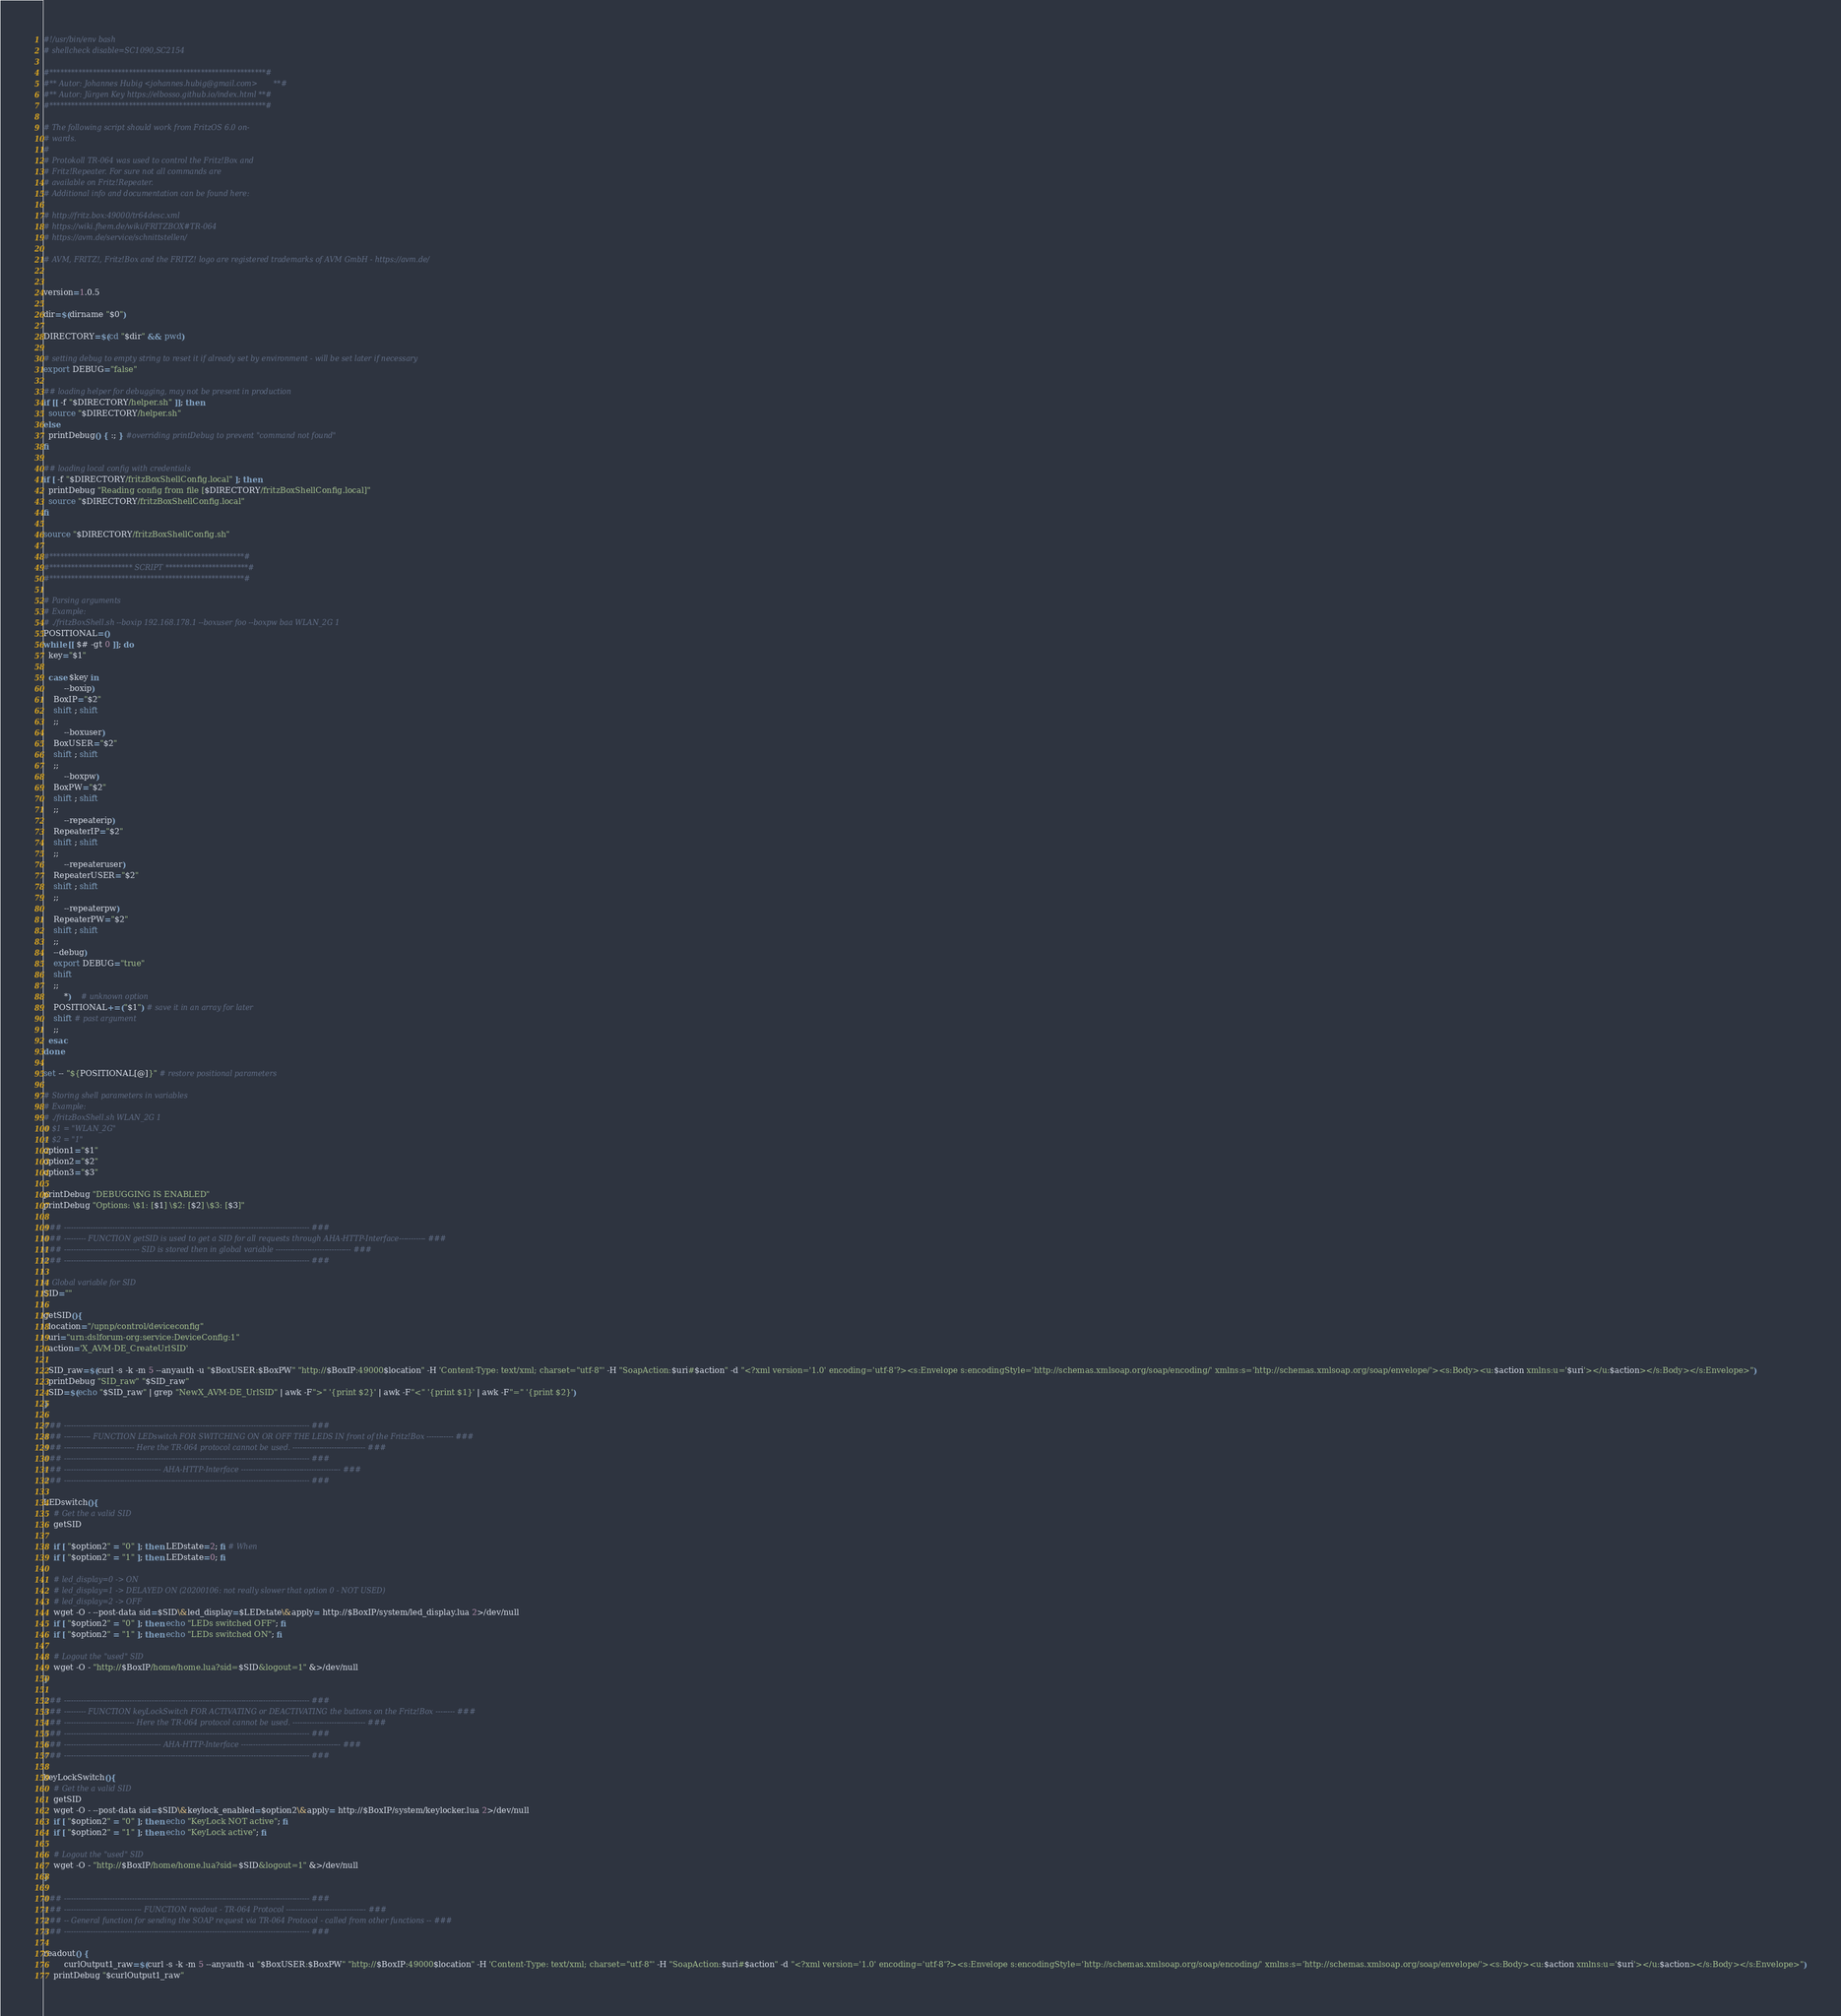<code> <loc_0><loc_0><loc_500><loc_500><_Bash_>#!/usr/bin/env bash
# shellcheck disable=SC1090,SC2154

#************************************************************#
#** Autor: Johannes Hubig <johannes.hubig@gmail.com>       **#
#** Autor: Jürgen Key https://elbosso.github.io/index.html **#
#************************************************************#

# The following script should work from FritzOS 6.0 on-
# wards.
#
# Protokoll TR-064 was used to control the Fritz!Box and
# Fritz!Repeater. For sure not all commands are
# available on Fritz!Repeater.
# Additional info and documentation can be found here:

# http://fritz.box:49000/tr64desc.xml
# https://wiki.fhem.de/wiki/FRITZBOX#TR-064
# https://avm.de/service/schnittstellen/

# AVM, FRITZ!, Fritz!Box and the FRITZ! logo are registered trademarks of AVM GmbH - https://avm.de/


version=1.0.5

dir=$(dirname "$0")

DIRECTORY=$(cd "$dir" && pwd)

# setting debug to empty string to reset it if already set by environment - will be set later if necessary
export DEBUG="false"

## loading helper for debugging, may not be present in production
if [[ -f "$DIRECTORY/helper.sh" ]]; then
  source "$DIRECTORY/helper.sh"
else
  printDebug() { :; } #overriding printDebug to prevent "command not found"
fi

## loading local config with credentials
if [ -f "$DIRECTORY/fritzBoxShellConfig.local" ]; then
  printDebug "Reading config from file [$DIRECTORY/fritzBoxShellConfig.local]"
  source "$DIRECTORY/fritzBoxShellConfig.local"
fi

source "$DIRECTORY/fritzBoxShellConfig.sh"

#******************************************************#
#*********************** SCRIPT ***********************#
#******************************************************#

# Parsing arguments
# Example:
# ./fritzBoxShell.sh --boxip 192.168.178.1 --boxuser foo --boxpw baa WLAN_2G 1
POSITIONAL=()
while [[ $# -gt 0 ]]; do
  key="$1"

  case $key in
		--boxip)
    BoxIP="$2"
    shift ; shift
    ;;
		--boxuser)
    BoxUSER="$2"
    shift ; shift
    ;;
		--boxpw)
    BoxPW="$2"
    shift ; shift
    ;;
		--repeaterip)
    RepeaterIP="$2"
    shift ; shift
    ;;
		--repeateruser)
    RepeaterUSER="$2"
    shift ; shift
    ;;
		--repeaterpw)
    RepeaterPW="$2"
    shift ; shift
    ;;
    --debug)
    export DEBUG="true"
    shift
    ;;
		*)    # unknown option
    POSITIONAL+=("$1") # save it in an array for later
    shift # past argument
    ;;
  esac
done

set -- "${POSITIONAL[@]}" # restore positional parameters

# Storing shell parameters in variables
# Example:
# ./fritzBoxShell.sh WLAN_2G 1
# $1 = "WLAN_2G"
# $2 = "1"
option1="$1"
option2="$2"
option3="$3"

printDebug "DEBUGGING IS ENABLED"
printDebug "Options: \$1: [$1] \$2: [$2] \$3: [$3]"

### ----------------------------------------------------------------------------------------------------- ###
### --------- FUNCTION getSID is used to get a SID for all requests through AHA-HTTP-Interface----------- ###
### ------------------------------- SID is stored then in global variable ------------------------------- ###
### ----------------------------------------------------------------------------------------------------- ###

# Global variable for SID
SID=""

getSID(){
  location="/upnp/control/deviceconfig"
  uri="urn:dslforum-org:service:DeviceConfig:1"
  action='X_AVM-DE_CreateUrlSID'

  SID_raw=$(curl -s -k -m 5 --anyauth -u "$BoxUSER:$BoxPW" "http://$BoxIP:49000$location" -H 'Content-Type: text/xml; charset="utf-8"' -H "SoapAction:$uri#$action" -d "<?xml version='1.0' encoding='utf-8'?><s:Envelope s:encodingStyle='http://schemas.xmlsoap.org/soap/encoding/' xmlns:s='http://schemas.xmlsoap.org/soap/envelope/'><s:Body><u:$action xmlns:u='$uri'></u:$action></s:Body></s:Envelope>")
  printDebug "SID_raw" "$SID_raw"
  SID=$(echo "$SID_raw" | grep "NewX_AVM-DE_UrlSID" | awk -F">" '{print $2}' | awk -F"<" '{print $1}' | awk -F"=" '{print $2}')
}

### ----------------------------------------------------------------------------------------------------- ###
### ----------- FUNCTION LEDswitch FOR SWITCHING ON OR OFF THE LEDS IN front of the Fritz!Box ----------- ###
### ----------------------------- Here the TR-064 protocol cannot be used. ------------------------------ ###
### ----------------------------------------------------------------------------------------------------- ###
### ---------------------------------------- AHA-HTTP-Interface ----------------------------------------- ###
### ----------------------------------------------------------------------------------------------------- ###

LEDswitch(){
	# Get the a valid SID
	getSID

	if [ "$option2" = "0" ]; then LEDstate=2; fi # When
	if [ "$option2" = "1" ]; then LEDstate=0; fi

	# led_display=0 -> ON
	# led_display=1 -> DELAYED ON (20200106: not really slower that option 0 - NOT USED)
	# led_display=2 -> OFF
	wget -O - --post-data sid=$SID\&led_display=$LEDstate\&apply= http://$BoxIP/system/led_display.lua 2>/dev/null
	if [ "$option2" = "0" ]; then echo "LEDs switched OFF"; fi
	if [ "$option2" = "1" ]; then echo "LEDs switched ON"; fi

	# Logout the "used" SID
	wget -O - "http://$BoxIP/home/home.lua?sid=$SID&logout=1" &>/dev/null
}

### ----------------------------------------------------------------------------------------------------- ###
### --------- FUNCTION keyLockSwitch FOR ACTIVATING or DEACTIVATING the buttons on the Fritz!Box -------- ###
### ----------------------------- Here the TR-064 protocol cannot be used. ------------------------------ ###
### ----------------------------------------------------------------------------------------------------- ###
### ---------------------------------------- AHA-HTTP-Interface ----------------------------------------- ###
### ----------------------------------------------------------------------------------------------------- ###

keyLockSwitch(){
	# Get the a valid SID
	getSID
	wget -O - --post-data sid=$SID\&keylock_enabled=$option2\&apply= http://$BoxIP/system/keylocker.lua 2>/dev/null
	if [ "$option2" = "0" ]; then echo "KeyLock NOT active"; fi
	if [ "$option2" = "1" ]; then echo "KeyLock active"; fi

	# Logout the "used" SID
	wget -O - "http://$BoxIP/home/home.lua?sid=$SID&logout=1" &>/dev/null
}

### ----------------------------------------------------------------------------------------------------- ###
### -------------------------------- FUNCTION readout - TR-064 Protocol --------------------------------- ###
### -- General function for sending the SOAP request via TR-064 Protocol - called from other functions -- ###
### ----------------------------------------------------------------------------------------------------- ###

readout() {
		curlOutput1_raw=$(curl -s -k -m 5 --anyauth -u "$BoxUSER:$BoxPW" "http://$BoxIP:49000$location" -H 'Content-Type: text/xml; charset="utf-8"' -H "SoapAction:$uri#$action" -d "<?xml version='1.0' encoding='utf-8'?><s:Envelope s:encodingStyle='http://schemas.xmlsoap.org/soap/encoding/' xmlns:s='http://schemas.xmlsoap.org/soap/envelope/'><s:Body><u:$action xmlns:u='$uri'></u:$action></s:Body></s:Envelope>")
    printDebug "$curlOutput1_raw"</code> 